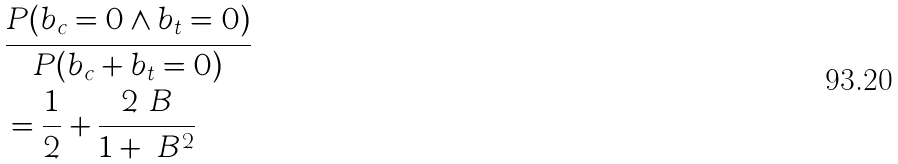<formula> <loc_0><loc_0><loc_500><loc_500>& \frac { P ( b _ { c } = 0 \wedge b _ { t } = 0 ) } { P ( b _ { c } + b _ { t } = 0 ) } \\ & = \frac { 1 } { 2 } + \frac { 2 \ B } { 1 + \ B ^ { 2 } }</formula> 